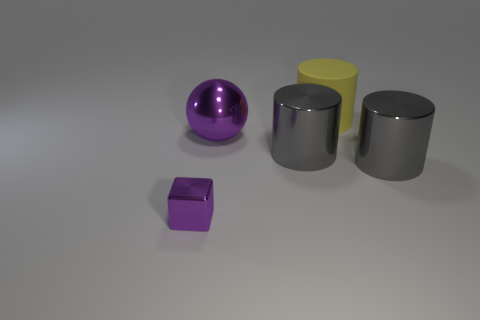Are there more yellow rubber things that are on the right side of the yellow cylinder than big yellow matte cylinders?
Ensure brevity in your answer.  No. What number of matte cylinders are the same size as the rubber object?
Your answer should be compact. 0. What size is the metallic cube that is the same color as the big ball?
Your answer should be very brief. Small. What number of big objects are either yellow matte cylinders or green objects?
Give a very brief answer. 1. What number of yellow things are there?
Ensure brevity in your answer.  1. Are there the same number of shiny cylinders on the left side of the big purple metal thing and large gray shiny cylinders that are in front of the yellow cylinder?
Give a very brief answer. No. Are there any big rubber cylinders on the right side of the yellow thing?
Provide a succinct answer. No. What color is the large object on the right side of the large rubber thing?
Offer a very short reply. Gray. The large object left of the large gray thing that is to the left of the yellow cylinder is made of what material?
Give a very brief answer. Metal. Is the number of purple things that are behind the large purple metallic thing less than the number of matte cylinders that are on the left side of the small purple metallic object?
Offer a terse response. No. 